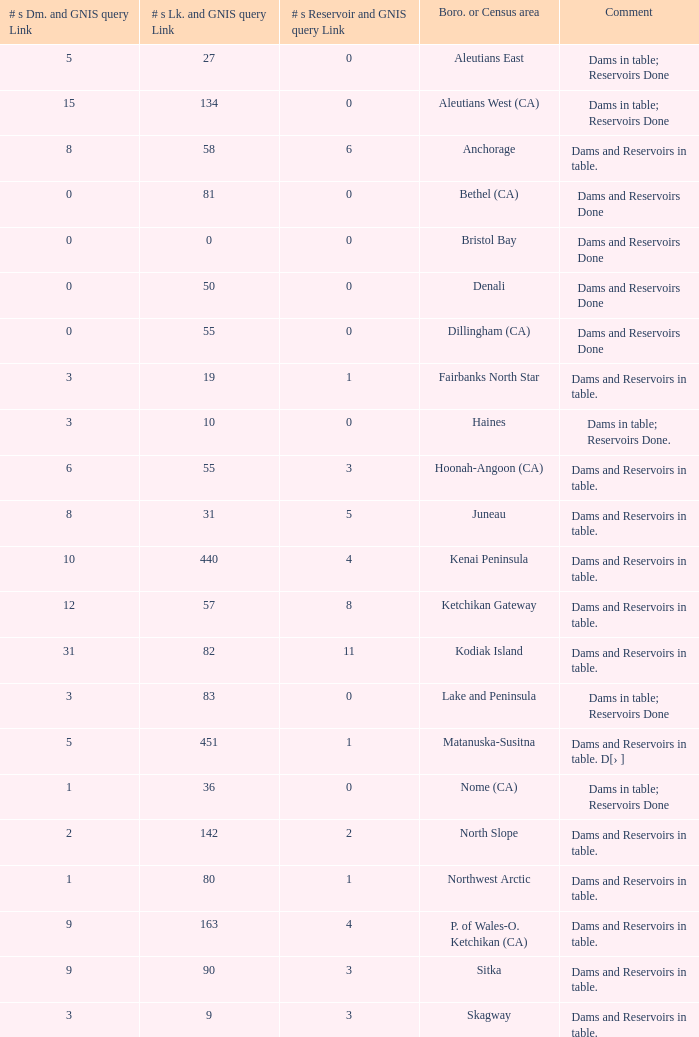Name the most numbers dam and gnis query link for borough or census area for fairbanks north star 3.0. 